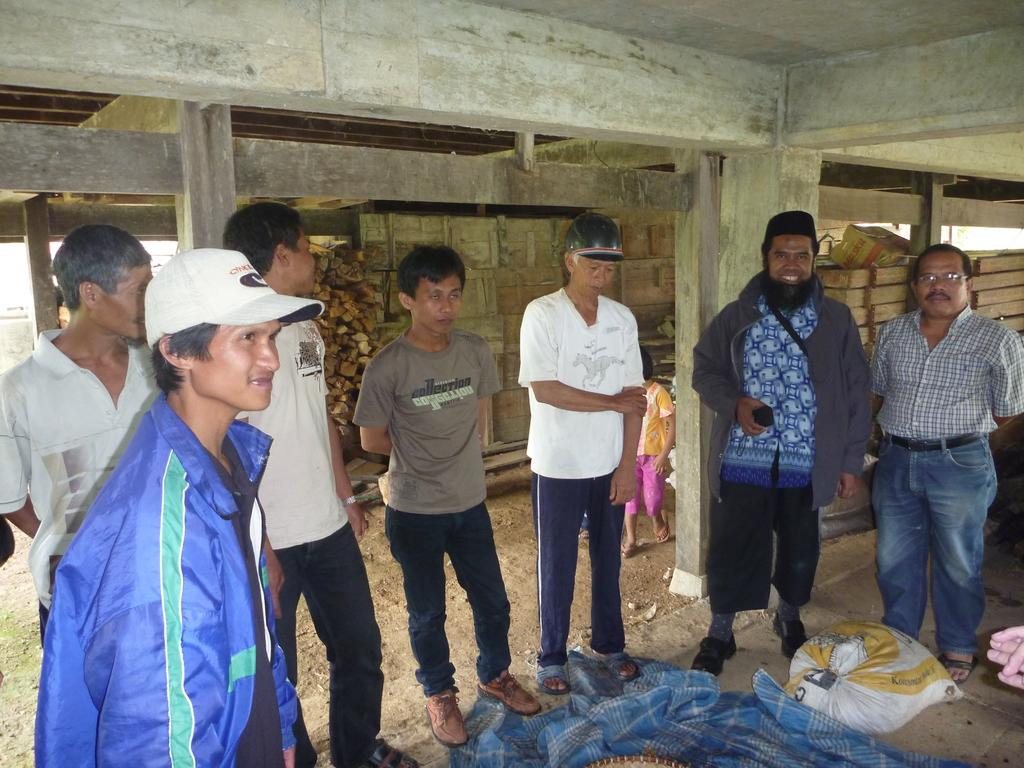Who or what is present in the image? There are people in the image. What is the facial expression of the people in the image? The people are smiling. What type of objects can be seen in the image? There are logs of wood and pillars in the image. What type of animal is rolling on the roof in the image? There is no animal rolling on the roof in the image. What type of roof is visible in the image? There is no roof visible in the image. 